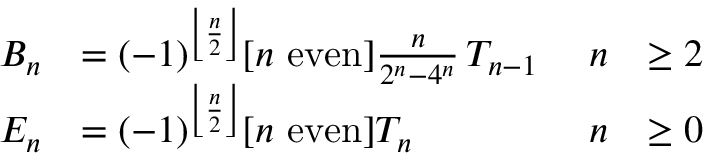Convert formula to latex. <formula><loc_0><loc_0><loc_500><loc_500>{ \begin{array} { r l r l } { B _ { n } } & { = ( - 1 ) ^ { \left \lfloor { \frac { n } { 2 } } \right \rfloor } [ n { e v e n } ] { \frac { n } { 2 ^ { n } - 4 ^ { n } } } \, T _ { n - 1 } \ } & { n } & { \geq 2 } \\ { E _ { n } } & { = ( - 1 ) ^ { \left \lfloor { \frac { n } { 2 } } \right \rfloor } [ n { e v e n } ] T _ { n } } & { n } & { \geq 0 } \end{array} }</formula> 